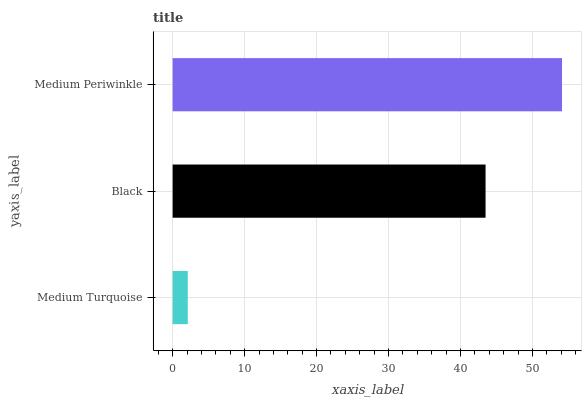Is Medium Turquoise the minimum?
Answer yes or no. Yes. Is Medium Periwinkle the maximum?
Answer yes or no. Yes. Is Black the minimum?
Answer yes or no. No. Is Black the maximum?
Answer yes or no. No. Is Black greater than Medium Turquoise?
Answer yes or no. Yes. Is Medium Turquoise less than Black?
Answer yes or no. Yes. Is Medium Turquoise greater than Black?
Answer yes or no. No. Is Black less than Medium Turquoise?
Answer yes or no. No. Is Black the high median?
Answer yes or no. Yes. Is Black the low median?
Answer yes or no. Yes. Is Medium Turquoise the high median?
Answer yes or no. No. Is Medium Turquoise the low median?
Answer yes or no. No. 